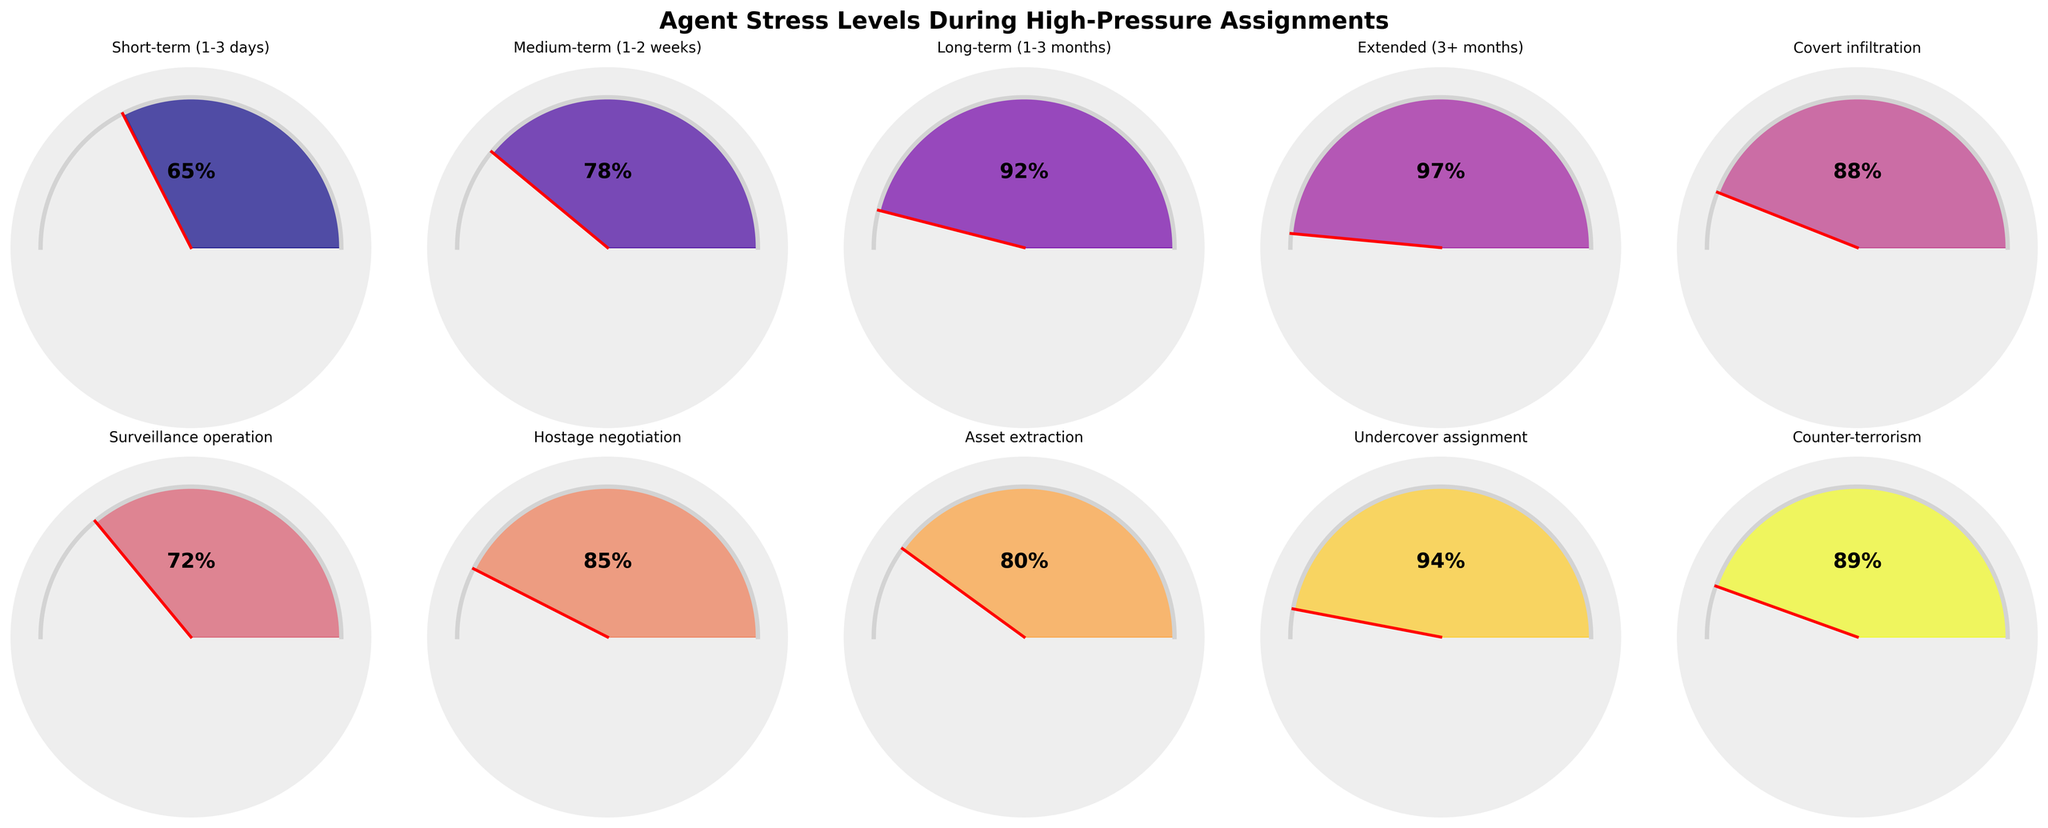What is the title of the figure? The title is found at the top of the figure, which usually summarizes what the data represents or the main topic.
Answer: Agent Stress Levels During High-Pressure Assignments How many categories of mission types are displayed in the figure? Count the number of distinct subplots or gauges, each representing a different category of mission duration.
Answer: 10 Which mission type has the highest stress level? Locate the gauge showing the highest percentage. This can usually be identified by the position of the needle and the filled area extending the farthest.
Answer: Extended (3+ months) What is the average stress level across all mission types? Sum all the stress levels for each mission type and divide by the number of categories. (65 + 78 + 92 + 97 + 88 + 72 + 85 + 80 + 94 + 89) / 10 = 84
Answer: 84 How does the stress level of an undercover assignment compare to a covert infiltration mission? Locate both missions, compare their stress levels by noting the value indicated by the needle in each gauge chart.
Answer: Undercover assignment has a higher stress level (94) compared to covert infiltration (88) Which mission types have a stress level below 80%? Identify all gauges where the needle points below the 80% mark and check the labels.
Answer: Short-term (1-3 days) and Surveillance operation What is the difference in stress level between the short-term assignment and the counter-terrorism mission? Subtract the stress level value of the short-term mission from the stress level of the counter-terrorism mission (89 - 65).
Answer: 24 Are there more high-stress missions (above 90%) or low-stress missions (below 70%)? Count the number of missions in both stress ranges. High stress: Long-term (1-3 months), Extended (3+ months), Undercover assignment (3 missions). Low stress: Short-term (1-3 days), Surveillance operation (2 missions).
Answer: High-stress missions What is the median stress level among the mission types? Arrange the stress levels in ascending order and find the middle value. Sorted: 65, 72, 78, 80, 85, 88, 89, 92, 94, 97. Median (middle value between the 5th and 6th values): (85 + 88) / 2 = 86.5
Answer: 86.5 Which mission category shows the most deviation from the average stress level of 84%? Calculate the absolute differences from the average (84) for each mission and identify the highest deviation. Deviations: 19, 6, 8, 13, 4, 12, 1, 4, 10, 5. The highest deviation is 19 for Short-term (1-3 days).
Answer: Short-term (1-3 days) 